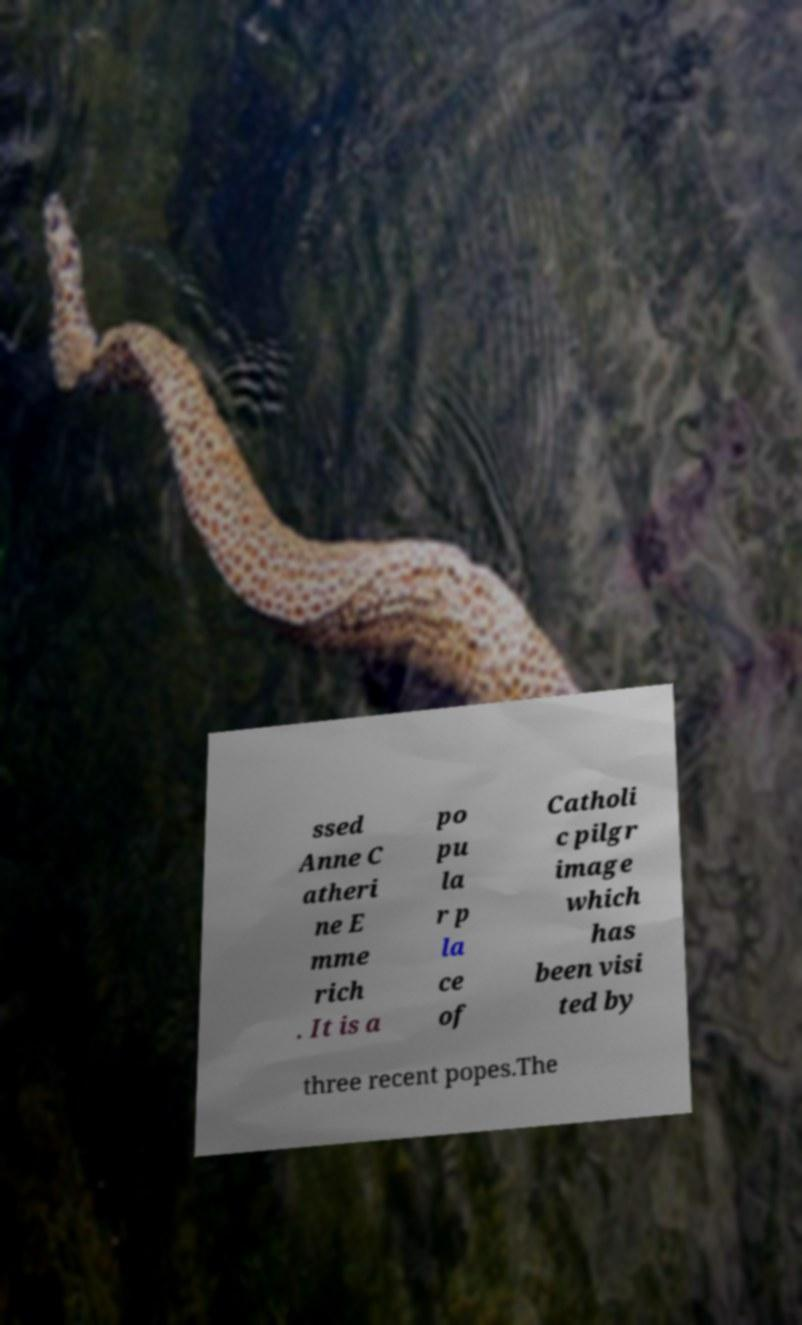Could you assist in decoding the text presented in this image and type it out clearly? ssed Anne C atheri ne E mme rich . It is a po pu la r p la ce of Catholi c pilgr image which has been visi ted by three recent popes.The 